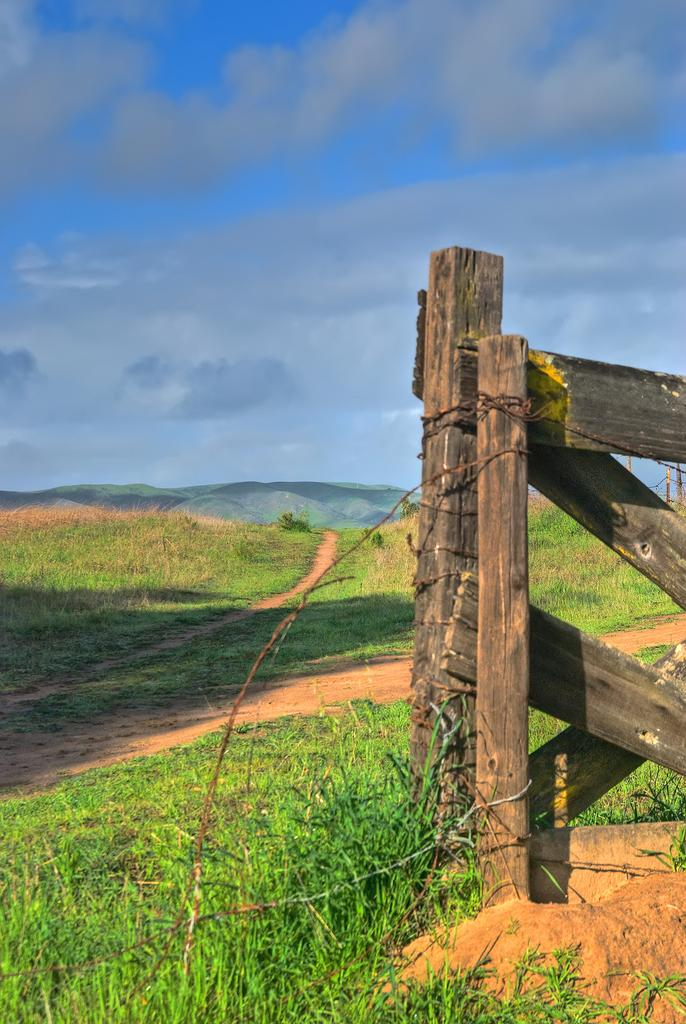What type of material is used for the railing on the right side of the image? The railing on the right side of the image is made of wood. What is covering the ground in the image? There is grass on the ground in the image. What can be seen in the sky in the background of the image? There are clouds in the sky in the background of the image. Are there any poisonous plants visible in the image? There is no mention of any plants, poisonous or otherwise, in the image. How does the mist affect the visibility in the image? There is no mention of mist in the image; it only describes clouds in the sky. 